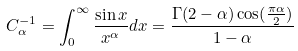Convert formula to latex. <formula><loc_0><loc_0><loc_500><loc_500>C _ { \alpha } ^ { - 1 } = \int _ { 0 } ^ { \infty } \frac { \sin x } { x ^ { \alpha } } d x = \frac { \Gamma ( 2 - \alpha ) \cos ( \frac { \pi \alpha } { 2 } ) } { 1 - \alpha }</formula> 